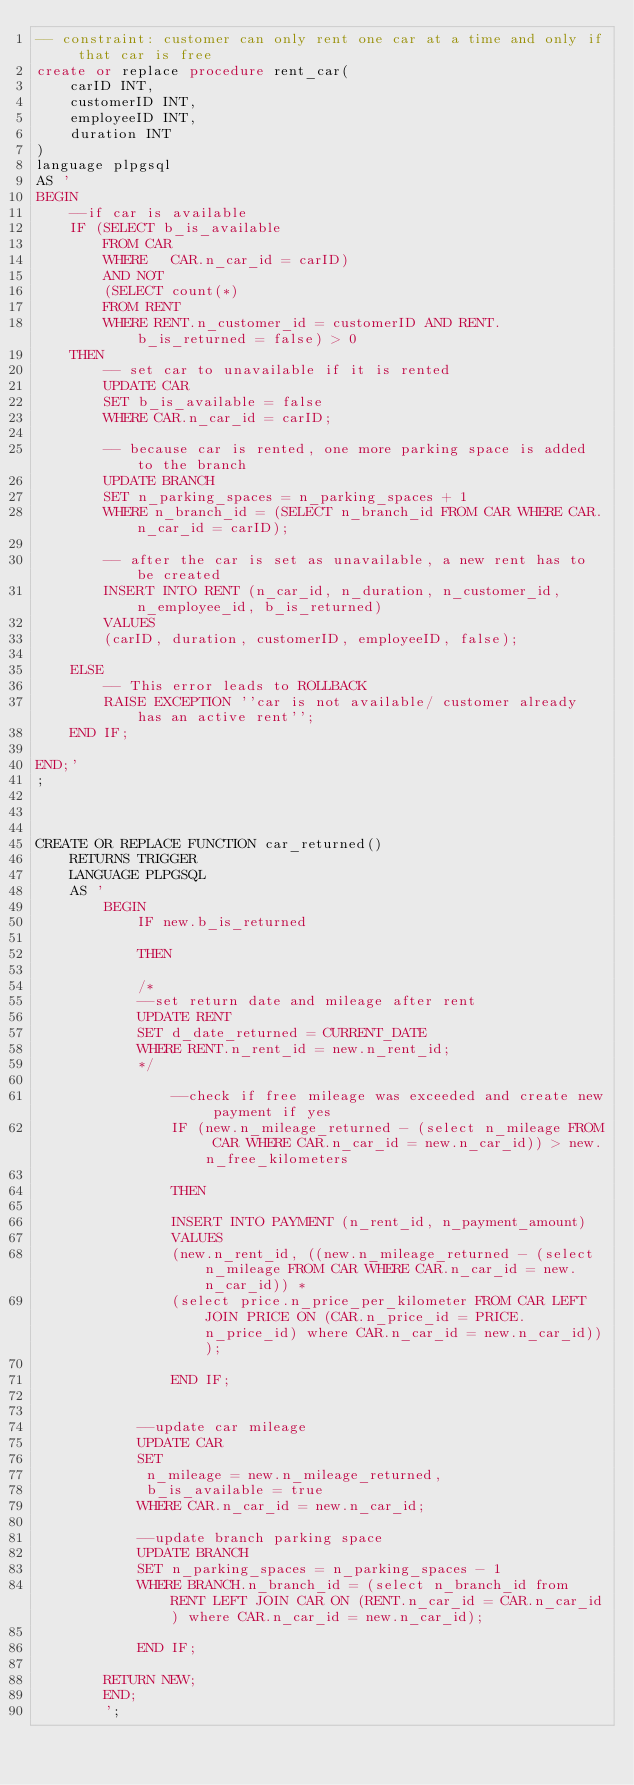<code> <loc_0><loc_0><loc_500><loc_500><_SQL_>-- constraint: customer can only rent one car at a time and only if that car is free
create or replace procedure rent_car( 
    carID INT,
    customerID INT,
    employeeID INT,
    duration INT
)
language plpgsql
AS '
BEGIN
    --if car is available
    IF (SELECT b_is_available
        FROM CAR
        WHERE   CAR.n_car_id = carID) 
        AND NOT
        (SELECT count(*)
        FROM RENT
        WHERE RENT.n_customer_id = customerID AND RENT.b_is_returned = false) > 0
    THEN
        -- set car to unavailable if it is rented
        UPDATE CAR
        SET b_is_available = false
        WHERE CAR.n_car_id = carID;

        -- because car is rented, one more parking space is added to the branch
        UPDATE BRANCH
        SET n_parking_spaces = n_parking_spaces + 1
        WHERE n_branch_id = (SELECT n_branch_id FROM CAR WHERE CAR.n_car_id = carID);

        -- after the car is set as unavailable, a new rent has to be created
        INSERT INTO RENT (n_car_id, n_duration, n_customer_id, n_employee_id, b_is_returned)
        VALUES
        (carID, duration, customerID, employeeID, false);
    
    ELSE 
        -- This error leads to ROLLBACK
        RAISE EXCEPTION ''car is not available/ customer already has an active rent''; 
    END IF;

END;'
;



CREATE OR REPLACE FUNCTION car_returned()
	RETURNS TRIGGER
	LANGUAGE PLPGSQL
	AS '
		BEGIN			
			IF new.b_is_returned
            
            THEN

            /*
            --set return date and mileage after rent
		    UPDATE RENT
			SET d_date_returned = CURRENT_DATE
		   	WHERE RENT.n_rent_id = new.n_rent_id;
            */

                --check if free mileage was exceeded and create new payment if yes
                IF (new.n_mileage_returned - (select n_mileage FROM CAR WHERE CAR.n_car_id = new.n_car_id)) > new.n_free_kilometers

                THEN 

                INSERT INTO PAYMENT (n_rent_id, n_payment_amount)
                VALUES
                (new.n_rent_id, ((new.n_mileage_returned - (select n_mileage FROM CAR WHERE CAR.n_car_id = new.n_car_id)) * 
                (select price.n_price_per_kilometer FROM CAR LEFT JOIN PRICE ON (CAR.n_price_id = PRICE.n_price_id) where CAR.n_car_id = new.n_car_id)));

                END IF;


            --update car mileage
            UPDATE CAR
            SET 
             n_mileage = new.n_mileage_returned,
             b_is_available = true
            WHERE CAR.n_car_id = new.n_car_id;

            --update branch parking space
            UPDATE BRANCH
            SET n_parking_spaces = n_parking_spaces - 1
            WHERE BRANCH.n_branch_id = (select n_branch_id from RENT LEFT JOIN CAR ON (RENT.n_car_id = CAR.n_car_id) where CAR.n_car_id = new.n_car_id);

	   	    END IF;
	   	
	   	RETURN NEW;
		END;
		';</code> 